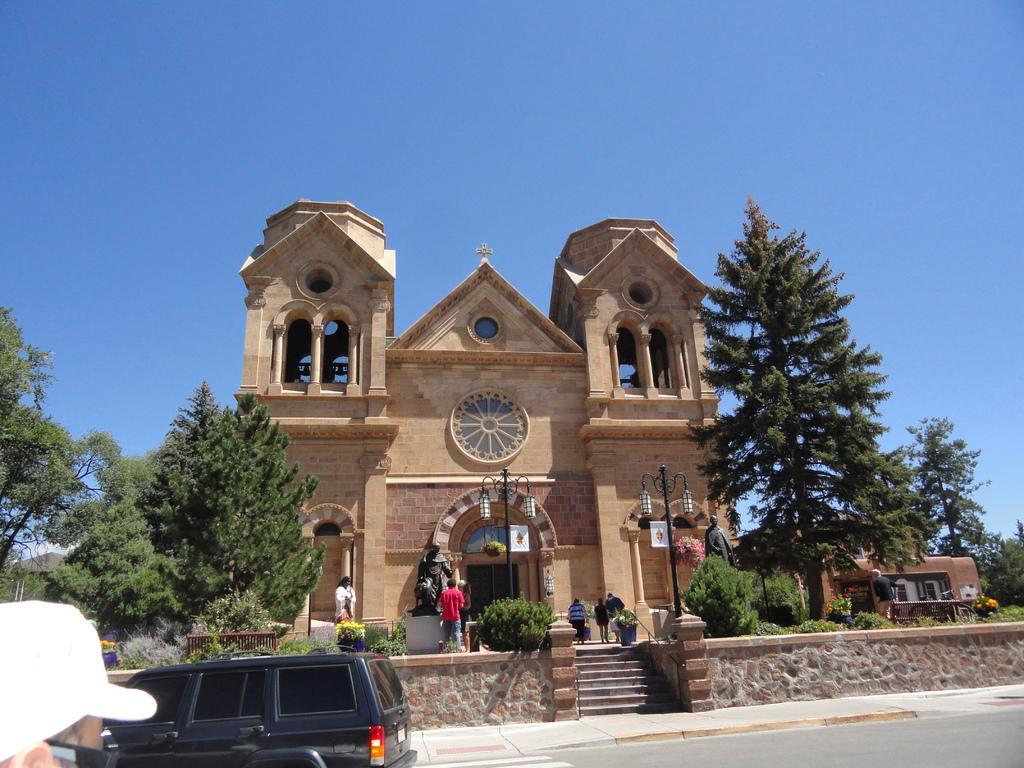How would you summarize this image in a sentence or two? In this image we can see a building and a house. There are many plants and trees in the image. There is a vehicle on the road. There are many people in the image. There is a blue and clear sky in the image. There are two lamps and two sculptures in the image. 